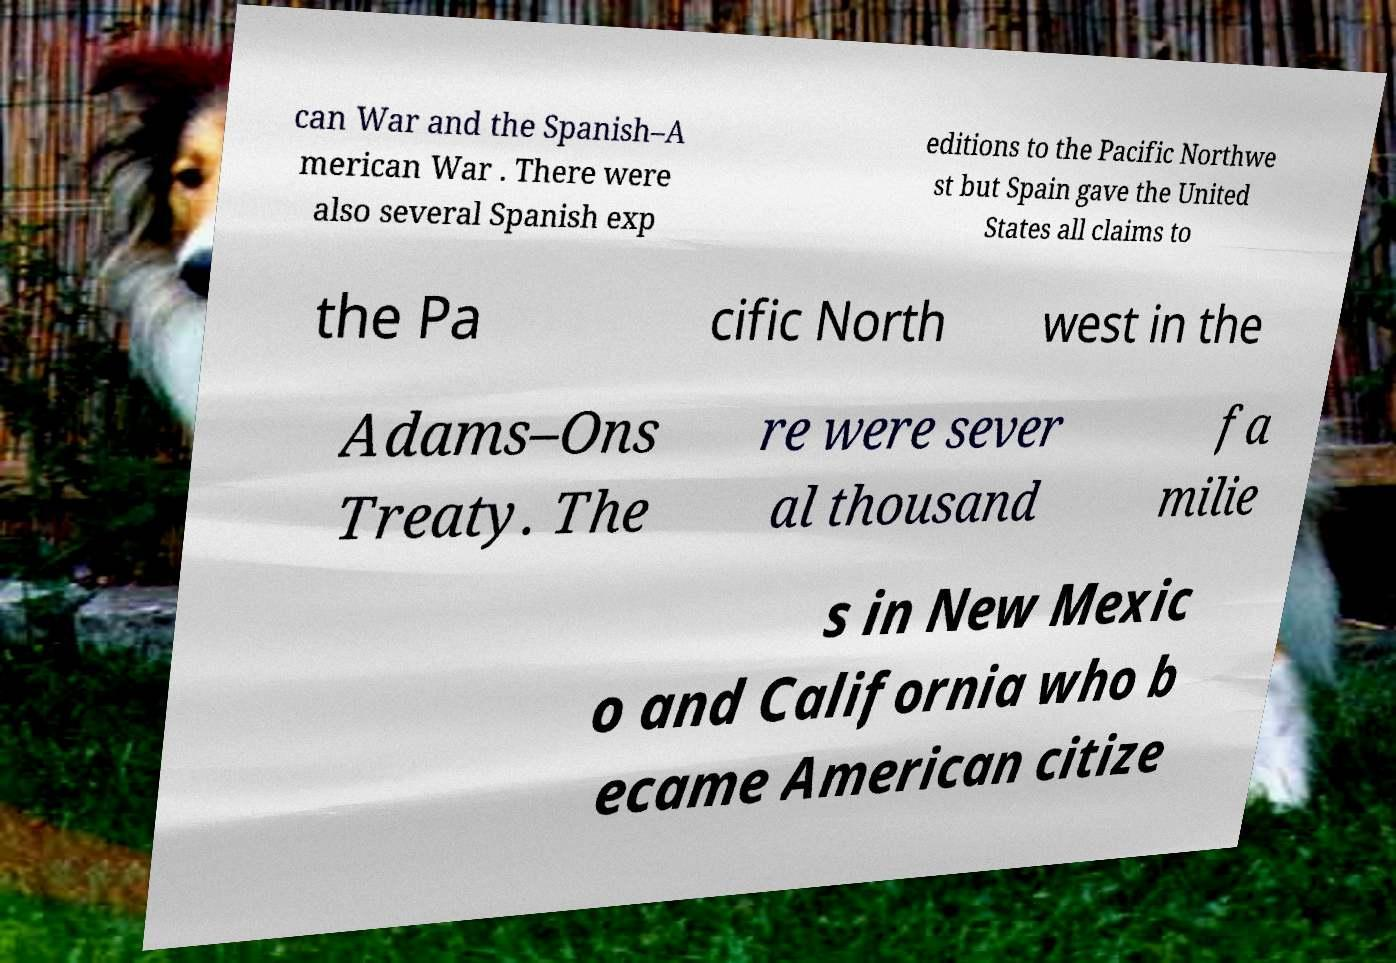Can you accurately transcribe the text from the provided image for me? can War and the Spanish–A merican War . There were also several Spanish exp editions to the Pacific Northwe st but Spain gave the United States all claims to the Pa cific North west in the Adams–Ons Treaty. The re were sever al thousand fa milie s in New Mexic o and California who b ecame American citize 